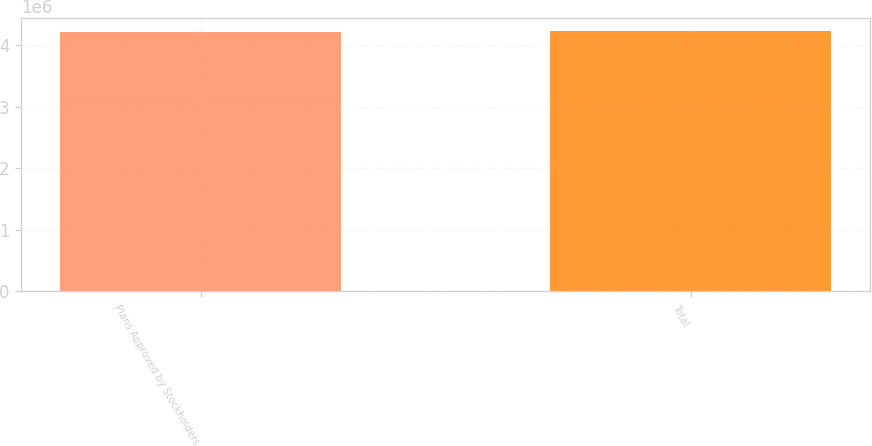<chart> <loc_0><loc_0><loc_500><loc_500><bar_chart><fcel>Plans Approved by Stockholders<fcel>Total<nl><fcel>4.20871e+06<fcel>4.23371e+06<nl></chart> 